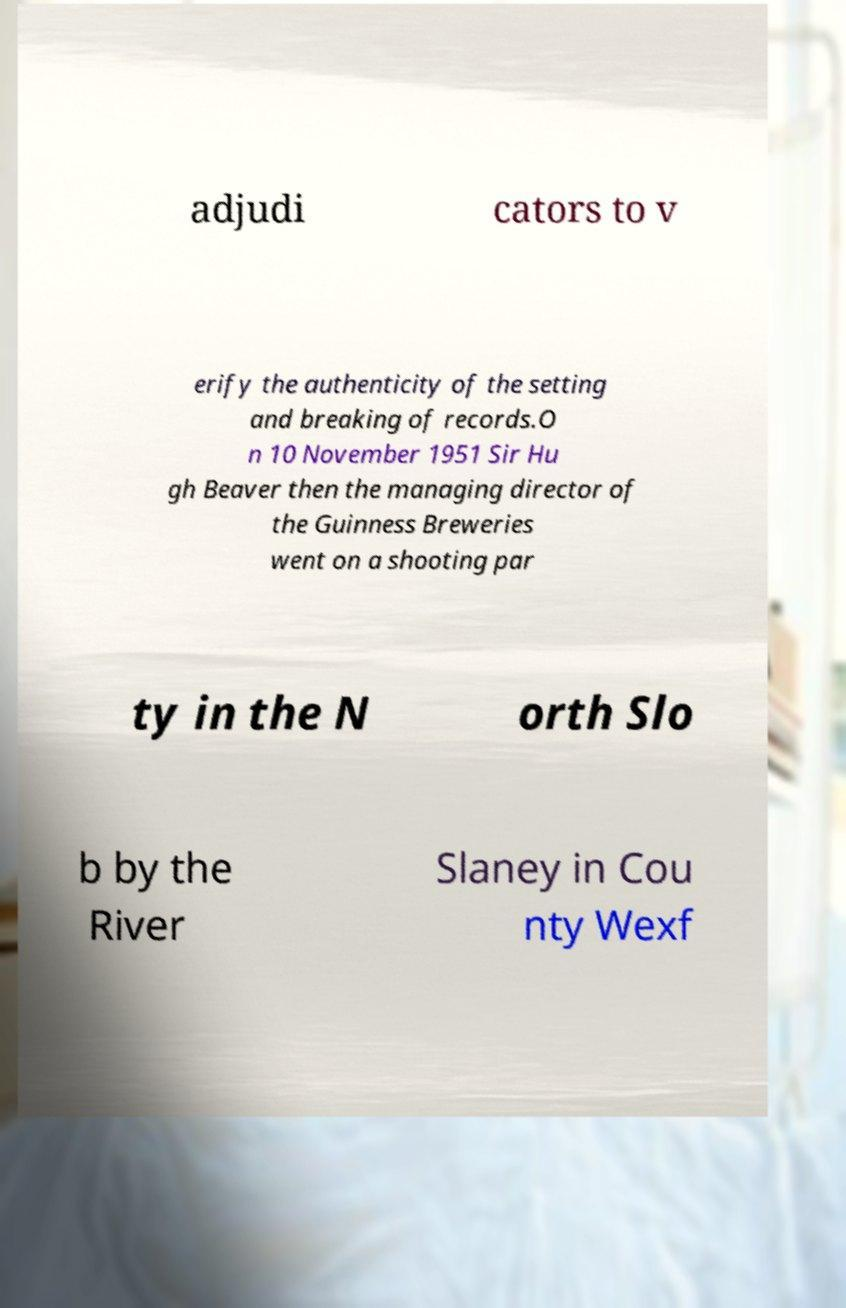Please read and relay the text visible in this image. What does it say? adjudi cators to v erify the authenticity of the setting and breaking of records.O n 10 November 1951 Sir Hu gh Beaver then the managing director of the Guinness Breweries went on a shooting par ty in the N orth Slo b by the River Slaney in Cou nty Wexf 